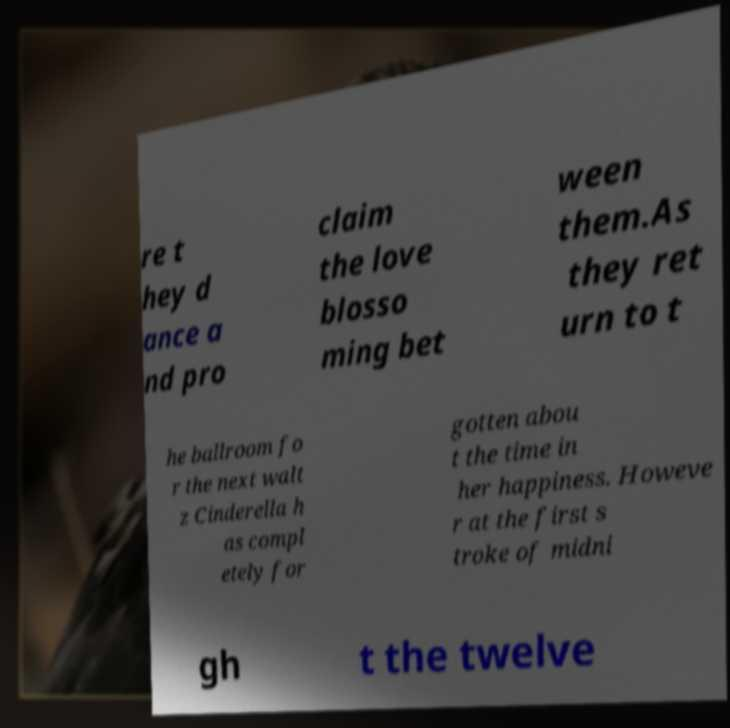Please read and relay the text visible in this image. What does it say? re t hey d ance a nd pro claim the love blosso ming bet ween them.As they ret urn to t he ballroom fo r the next walt z Cinderella h as compl etely for gotten abou t the time in her happiness. Howeve r at the first s troke of midni gh t the twelve 